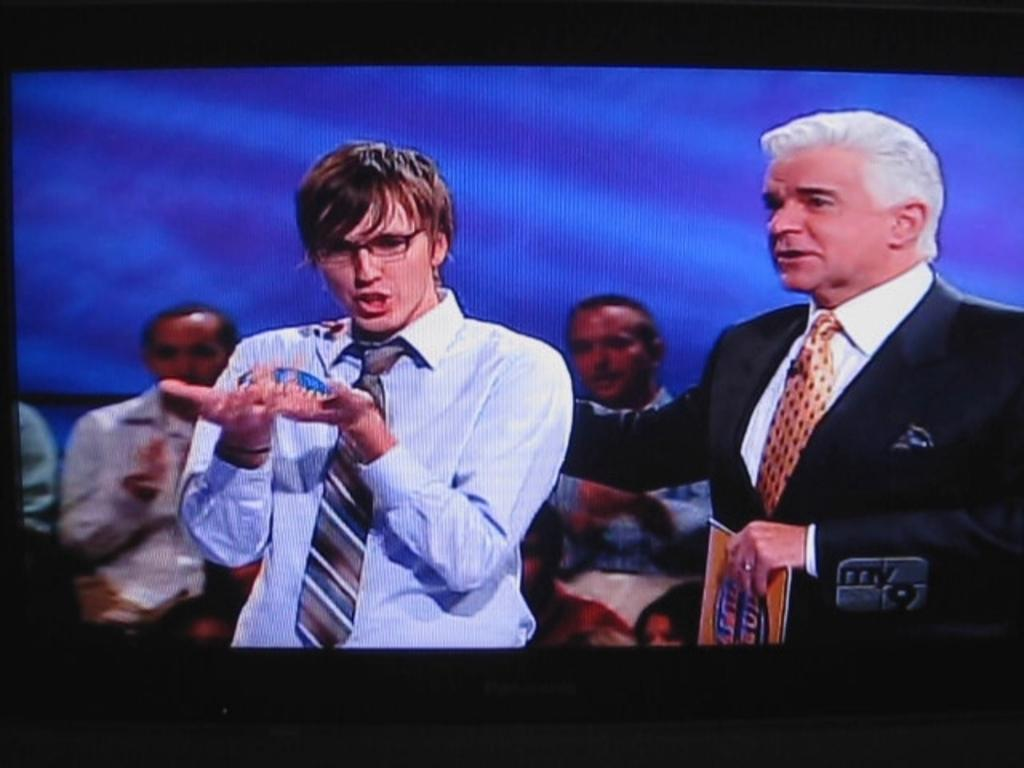Provide a one-sentence caption for the provided image. A screen shot from a TV programming on my 9. 